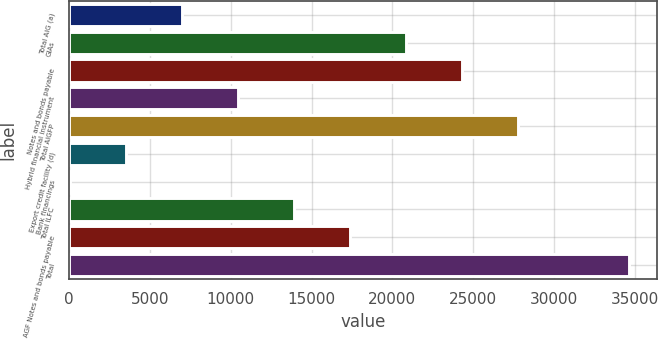Convert chart. <chart><loc_0><loc_0><loc_500><loc_500><bar_chart><fcel>Total AIG (a)<fcel>GIAs<fcel>Notes and bonds payable<fcel>Hybrid financial instrument<fcel>Total AIGFP<fcel>Export credit facility (d)<fcel>Bank financings<fcel>Total ILFC<fcel>AGF Notes and bonds payable<fcel>Total<nl><fcel>6994<fcel>20832<fcel>24291.5<fcel>10453.5<fcel>27751<fcel>3534.5<fcel>75<fcel>13913<fcel>17372.5<fcel>34670<nl></chart> 